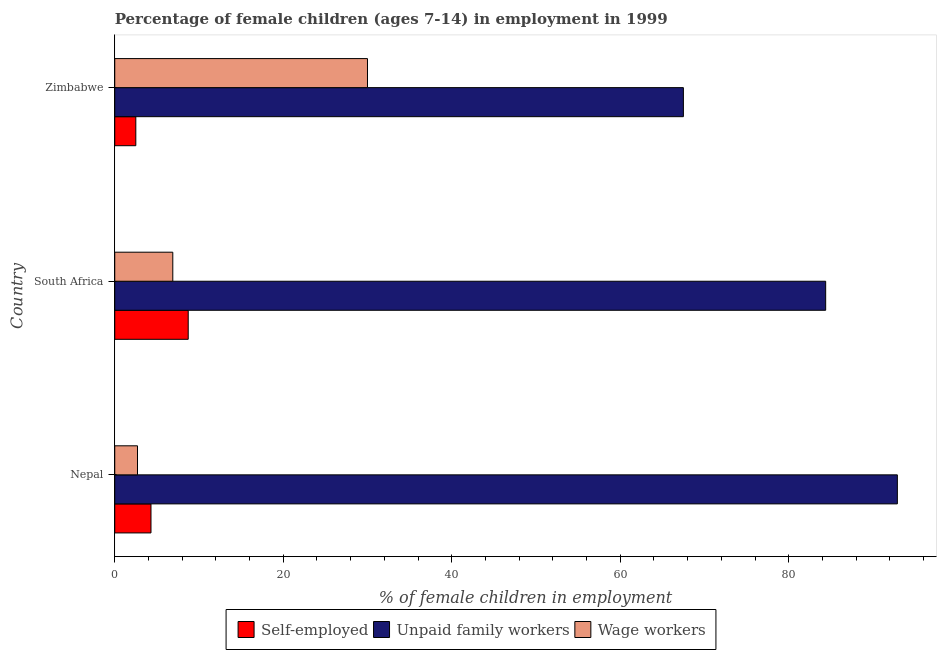How many different coloured bars are there?
Your response must be concise. 3. How many groups of bars are there?
Your response must be concise. 3. Are the number of bars on each tick of the Y-axis equal?
Your answer should be very brief. Yes. How many bars are there on the 1st tick from the top?
Your answer should be very brief. 3. What is the label of the 1st group of bars from the top?
Offer a terse response. Zimbabwe. What is the percentage of self employed children in South Africa?
Make the answer very short. 8.72. Across all countries, what is the maximum percentage of children employed as unpaid family workers?
Your answer should be compact. 92.9. Across all countries, what is the minimum percentage of children employed as unpaid family workers?
Provide a short and direct response. 67.5. In which country was the percentage of children employed as wage workers maximum?
Provide a short and direct response. Zimbabwe. In which country was the percentage of self employed children minimum?
Provide a short and direct response. Zimbabwe. What is the total percentage of children employed as unpaid family workers in the graph?
Your answer should be very brief. 244.79. What is the difference between the percentage of children employed as unpaid family workers in Nepal and that in South Africa?
Keep it short and to the point. 8.51. What is the difference between the percentage of children employed as unpaid family workers in Zimbabwe and the percentage of self employed children in Nepal?
Your answer should be very brief. 63.2. What is the average percentage of self employed children per country?
Offer a terse response. 5.17. What is the difference between the percentage of self employed children and percentage of children employed as unpaid family workers in Zimbabwe?
Your response must be concise. -65. In how many countries, is the percentage of self employed children greater than 60 %?
Keep it short and to the point. 0. What is the ratio of the percentage of children employed as wage workers in Nepal to that in South Africa?
Your answer should be very brief. 0.39. Is the percentage of children employed as wage workers in Nepal less than that in South Africa?
Your answer should be compact. Yes. What is the difference between the highest and the second highest percentage of children employed as unpaid family workers?
Make the answer very short. 8.51. What is the difference between the highest and the lowest percentage of children employed as unpaid family workers?
Ensure brevity in your answer.  25.4. What does the 1st bar from the top in Nepal represents?
Give a very brief answer. Wage workers. What does the 2nd bar from the bottom in Zimbabwe represents?
Provide a short and direct response. Unpaid family workers. How many countries are there in the graph?
Your response must be concise. 3. Are the values on the major ticks of X-axis written in scientific E-notation?
Give a very brief answer. No. Does the graph contain grids?
Ensure brevity in your answer.  No. How many legend labels are there?
Give a very brief answer. 3. How are the legend labels stacked?
Offer a terse response. Horizontal. What is the title of the graph?
Provide a short and direct response. Percentage of female children (ages 7-14) in employment in 1999. What is the label or title of the X-axis?
Provide a short and direct response. % of female children in employment. What is the % of female children in employment of Self-employed in Nepal?
Offer a terse response. 4.3. What is the % of female children in employment in Unpaid family workers in Nepal?
Provide a short and direct response. 92.9. What is the % of female children in employment of Wage workers in Nepal?
Give a very brief answer. 2.7. What is the % of female children in employment of Self-employed in South Africa?
Your response must be concise. 8.72. What is the % of female children in employment of Unpaid family workers in South Africa?
Offer a very short reply. 84.39. What is the % of female children in employment of Wage workers in South Africa?
Your response must be concise. 6.89. What is the % of female children in employment of Unpaid family workers in Zimbabwe?
Your answer should be compact. 67.5. Across all countries, what is the maximum % of female children in employment in Self-employed?
Offer a very short reply. 8.72. Across all countries, what is the maximum % of female children in employment of Unpaid family workers?
Your answer should be compact. 92.9. Across all countries, what is the minimum % of female children in employment of Unpaid family workers?
Give a very brief answer. 67.5. Across all countries, what is the minimum % of female children in employment of Wage workers?
Keep it short and to the point. 2.7. What is the total % of female children in employment of Self-employed in the graph?
Ensure brevity in your answer.  15.52. What is the total % of female children in employment in Unpaid family workers in the graph?
Give a very brief answer. 244.79. What is the total % of female children in employment in Wage workers in the graph?
Your answer should be compact. 39.59. What is the difference between the % of female children in employment in Self-employed in Nepal and that in South Africa?
Offer a very short reply. -4.42. What is the difference between the % of female children in employment in Unpaid family workers in Nepal and that in South Africa?
Ensure brevity in your answer.  8.51. What is the difference between the % of female children in employment in Wage workers in Nepal and that in South Africa?
Your answer should be very brief. -4.19. What is the difference between the % of female children in employment of Unpaid family workers in Nepal and that in Zimbabwe?
Keep it short and to the point. 25.4. What is the difference between the % of female children in employment in Wage workers in Nepal and that in Zimbabwe?
Provide a short and direct response. -27.3. What is the difference between the % of female children in employment of Self-employed in South Africa and that in Zimbabwe?
Your answer should be very brief. 6.22. What is the difference between the % of female children in employment in Unpaid family workers in South Africa and that in Zimbabwe?
Ensure brevity in your answer.  16.89. What is the difference between the % of female children in employment in Wage workers in South Africa and that in Zimbabwe?
Your answer should be compact. -23.11. What is the difference between the % of female children in employment of Self-employed in Nepal and the % of female children in employment of Unpaid family workers in South Africa?
Offer a terse response. -80.09. What is the difference between the % of female children in employment of Self-employed in Nepal and the % of female children in employment of Wage workers in South Africa?
Offer a terse response. -2.59. What is the difference between the % of female children in employment in Unpaid family workers in Nepal and the % of female children in employment in Wage workers in South Africa?
Ensure brevity in your answer.  86.01. What is the difference between the % of female children in employment of Self-employed in Nepal and the % of female children in employment of Unpaid family workers in Zimbabwe?
Make the answer very short. -63.2. What is the difference between the % of female children in employment in Self-employed in Nepal and the % of female children in employment in Wage workers in Zimbabwe?
Offer a terse response. -25.7. What is the difference between the % of female children in employment of Unpaid family workers in Nepal and the % of female children in employment of Wage workers in Zimbabwe?
Offer a very short reply. 62.9. What is the difference between the % of female children in employment in Self-employed in South Africa and the % of female children in employment in Unpaid family workers in Zimbabwe?
Your response must be concise. -58.78. What is the difference between the % of female children in employment in Self-employed in South Africa and the % of female children in employment in Wage workers in Zimbabwe?
Offer a very short reply. -21.28. What is the difference between the % of female children in employment of Unpaid family workers in South Africa and the % of female children in employment of Wage workers in Zimbabwe?
Ensure brevity in your answer.  54.39. What is the average % of female children in employment of Self-employed per country?
Make the answer very short. 5.17. What is the average % of female children in employment in Unpaid family workers per country?
Offer a terse response. 81.6. What is the average % of female children in employment in Wage workers per country?
Make the answer very short. 13.2. What is the difference between the % of female children in employment of Self-employed and % of female children in employment of Unpaid family workers in Nepal?
Offer a terse response. -88.6. What is the difference between the % of female children in employment of Self-employed and % of female children in employment of Wage workers in Nepal?
Offer a terse response. 1.6. What is the difference between the % of female children in employment of Unpaid family workers and % of female children in employment of Wage workers in Nepal?
Your answer should be compact. 90.2. What is the difference between the % of female children in employment in Self-employed and % of female children in employment in Unpaid family workers in South Africa?
Your answer should be compact. -75.67. What is the difference between the % of female children in employment in Self-employed and % of female children in employment in Wage workers in South Africa?
Your answer should be very brief. 1.83. What is the difference between the % of female children in employment in Unpaid family workers and % of female children in employment in Wage workers in South Africa?
Make the answer very short. 77.5. What is the difference between the % of female children in employment in Self-employed and % of female children in employment in Unpaid family workers in Zimbabwe?
Your response must be concise. -65. What is the difference between the % of female children in employment in Self-employed and % of female children in employment in Wage workers in Zimbabwe?
Make the answer very short. -27.5. What is the difference between the % of female children in employment in Unpaid family workers and % of female children in employment in Wage workers in Zimbabwe?
Make the answer very short. 37.5. What is the ratio of the % of female children in employment of Self-employed in Nepal to that in South Africa?
Keep it short and to the point. 0.49. What is the ratio of the % of female children in employment in Unpaid family workers in Nepal to that in South Africa?
Offer a terse response. 1.1. What is the ratio of the % of female children in employment of Wage workers in Nepal to that in South Africa?
Ensure brevity in your answer.  0.39. What is the ratio of the % of female children in employment in Self-employed in Nepal to that in Zimbabwe?
Give a very brief answer. 1.72. What is the ratio of the % of female children in employment in Unpaid family workers in Nepal to that in Zimbabwe?
Make the answer very short. 1.38. What is the ratio of the % of female children in employment in Wage workers in Nepal to that in Zimbabwe?
Provide a succinct answer. 0.09. What is the ratio of the % of female children in employment of Self-employed in South Africa to that in Zimbabwe?
Offer a very short reply. 3.49. What is the ratio of the % of female children in employment of Unpaid family workers in South Africa to that in Zimbabwe?
Provide a succinct answer. 1.25. What is the ratio of the % of female children in employment in Wage workers in South Africa to that in Zimbabwe?
Provide a succinct answer. 0.23. What is the difference between the highest and the second highest % of female children in employment in Self-employed?
Keep it short and to the point. 4.42. What is the difference between the highest and the second highest % of female children in employment in Unpaid family workers?
Your answer should be compact. 8.51. What is the difference between the highest and the second highest % of female children in employment of Wage workers?
Your response must be concise. 23.11. What is the difference between the highest and the lowest % of female children in employment of Self-employed?
Give a very brief answer. 6.22. What is the difference between the highest and the lowest % of female children in employment in Unpaid family workers?
Provide a succinct answer. 25.4. What is the difference between the highest and the lowest % of female children in employment of Wage workers?
Provide a succinct answer. 27.3. 